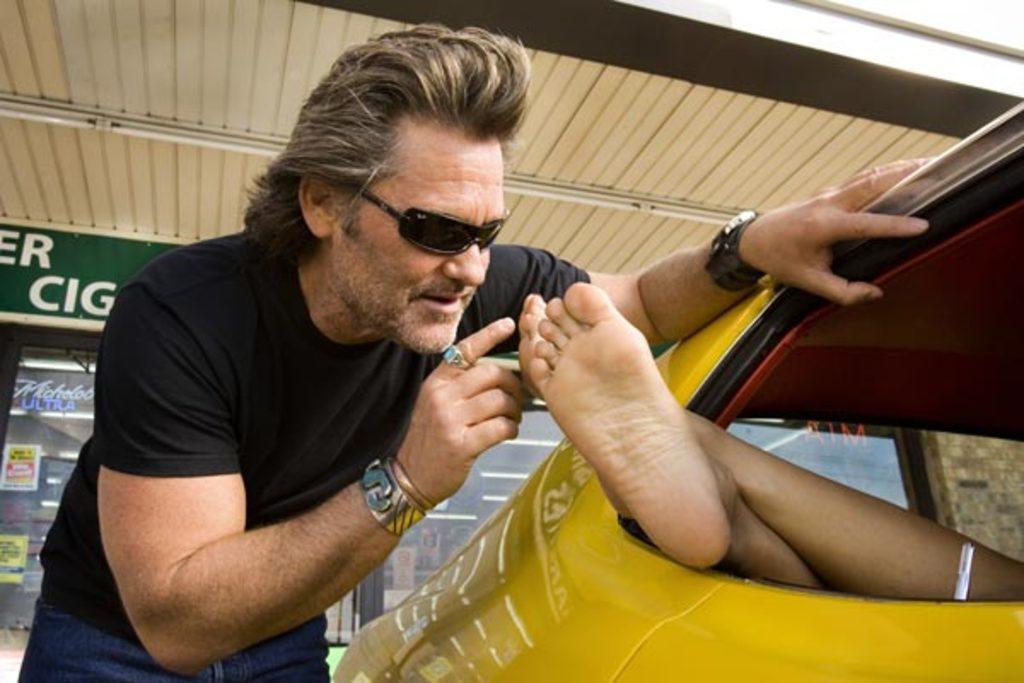In one or two sentences, can you explain what this image depicts? On the left side, there is a person in a black color t-shirt, wearing a black color t-shirt, wearing sunglasses, placing a hand on the yellow color vehicle and keeping a finger of the other hand near two legs of the person who is in the yellow color vehicle. In the background, there is a roof and there is a hoarding attached to the wall of a building, which is having glass windows, on which there are posters pasted. 